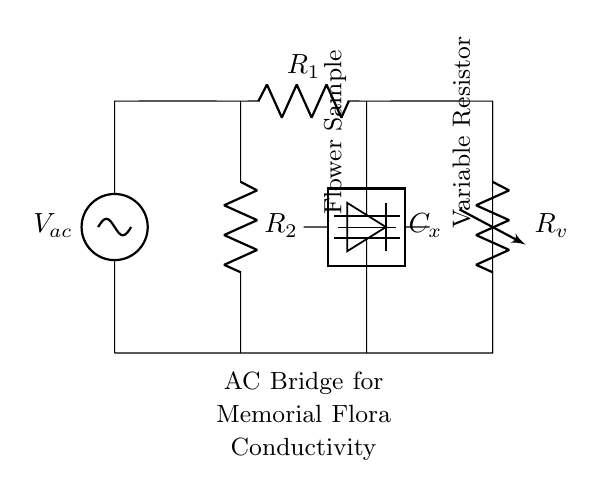what type of circuit is this? This circuit is an AC bridge circuit, characterized by its alternating current design, typically used to measure various electrical properties. The presence of components like resistors and capacitors connected to an AC voltage source confirms it's an AC bridge.
Answer: AC bridge what is the purpose of the variable resistor in this circuit? The variable resistor, labeled as Rv, is used to balance the bridge circuit. By adjusting its resistance, it ensures the detector reads zero, allowing the user to infer the conductivity of the flower sample by observing the balancing condition.
Answer: To balance the bridge how many resistors are in this circuit? There are three resistors in the circuit: R1, R2, and Rv. Each serves a different purpose in determining the conductivity but collectively must be analyzed to solve the bridge. Counting gives three.
Answer: Three what component measures the conductivity of the flower sample? The component that measures the conductivity is represented by the detector, located between two nodes of the bridge circuit. Its function is to indicate the balance state, which corresponds to the conductivity of the sample.
Answer: Detector what is the missing component represented by Cx? Cx is a capacitor, which is used for its reactance in the AC circuit, affecting the overall impedance. This is crucial for the frequency response of the circuit and helps determine the conductivity of the flower sample.
Answer: Capacitor what happens when the bridge is balanced? When the bridge is balanced, the detector reads zero, indicating that the ratio of the resistances and the reactance in the circuit is equal, which allows for a precise measurement of the flower's conductivity. This balance is the desired condition for accurate readings.
Answer: Detector reads zero 